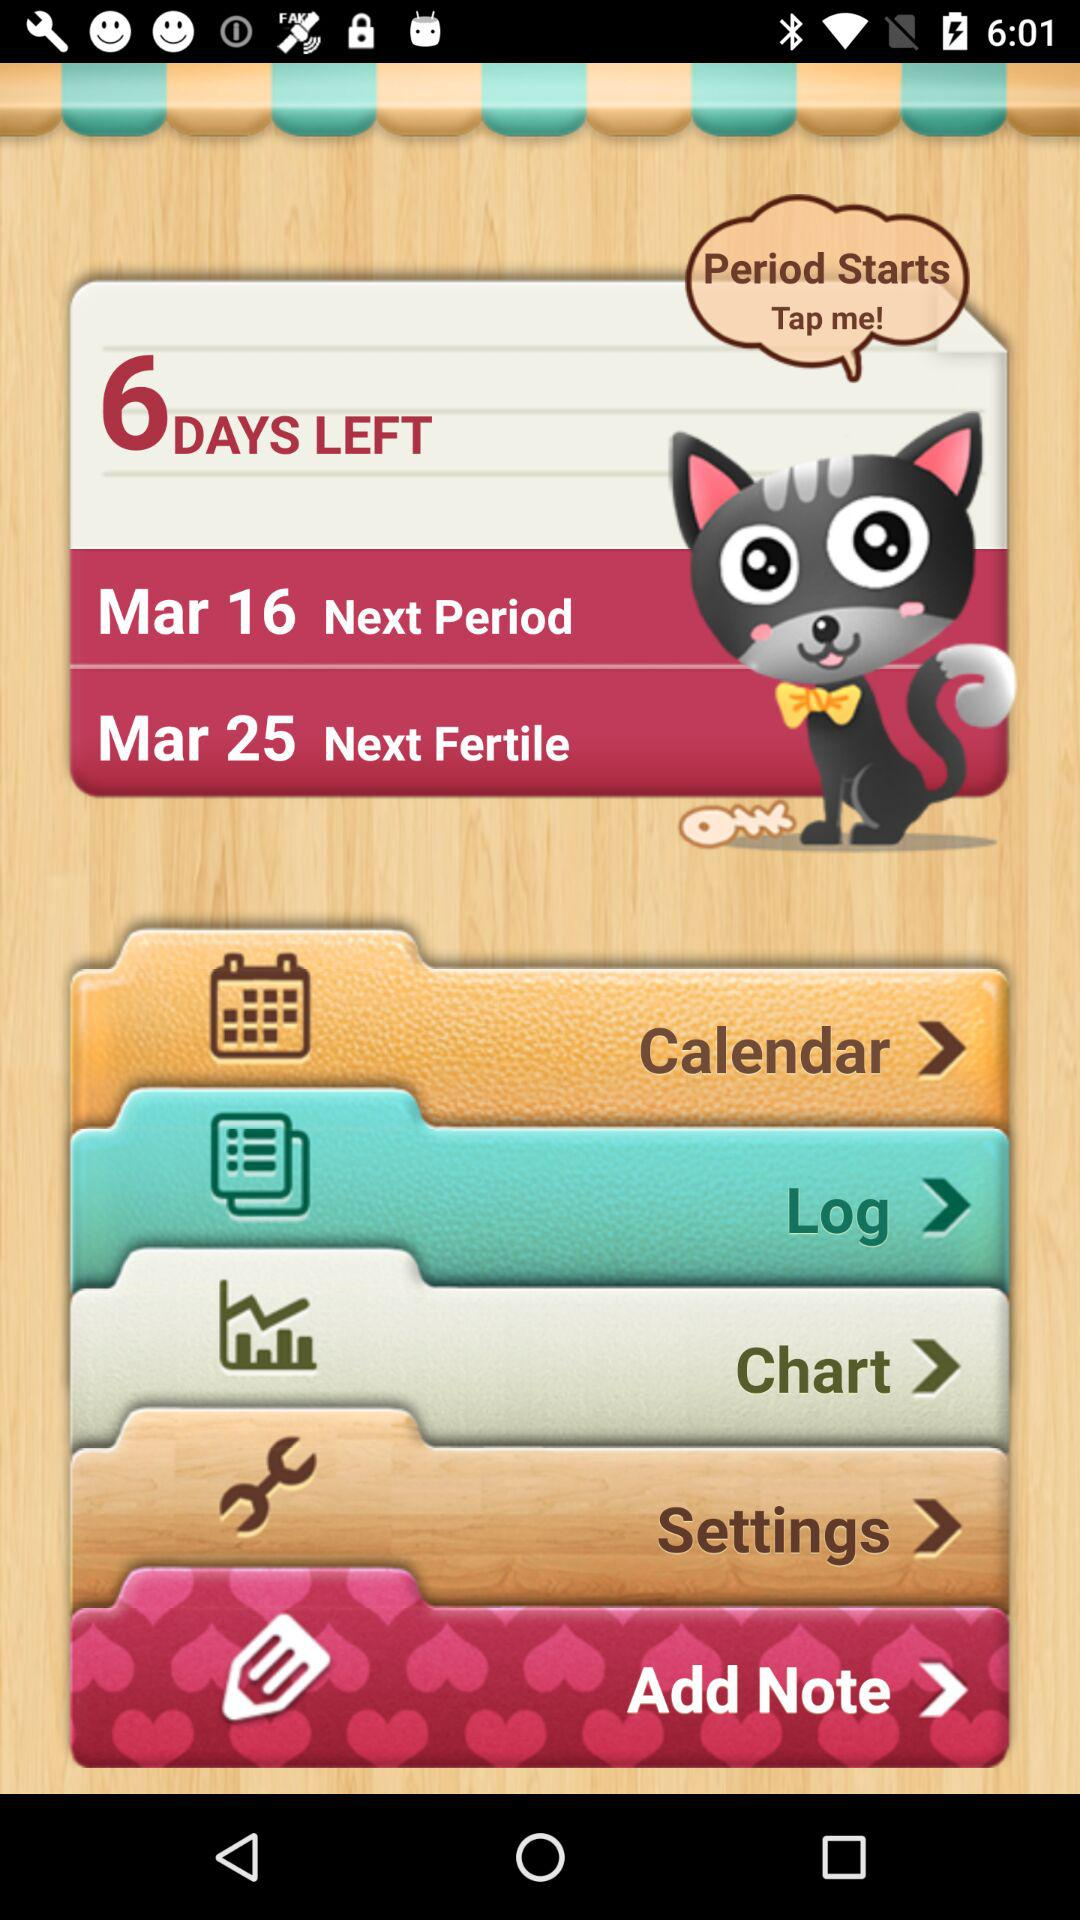How many notifications are there in "Settings"?
When the provided information is insufficient, respond with <no answer>. <no answer> 